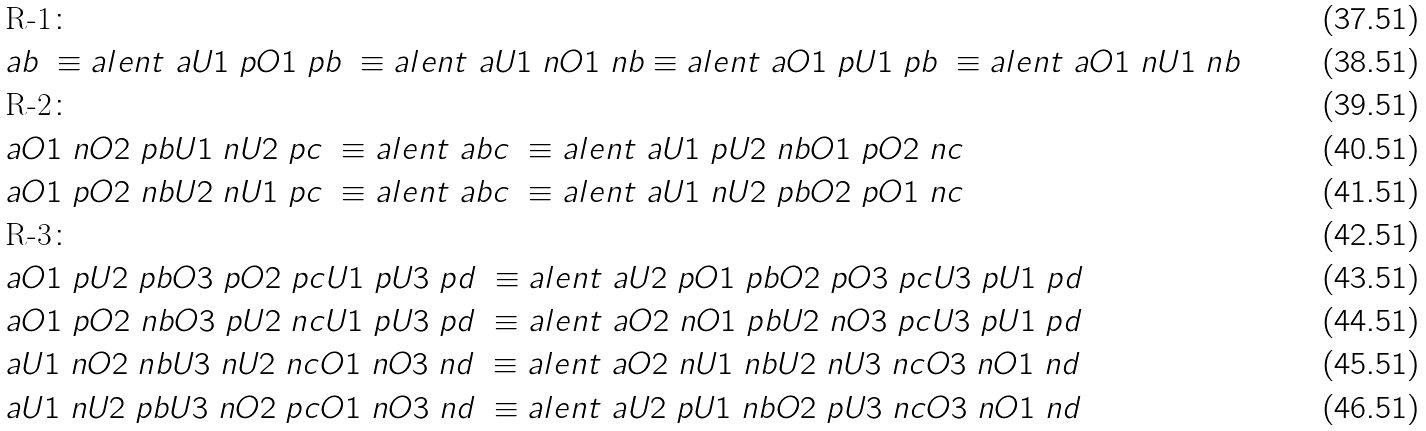<formula> <loc_0><loc_0><loc_500><loc_500>& \text {R-1} \colon \\ & a b \ \equiv a l e n t \ a U 1 \ p O 1 \ p b \ \equiv a l e n t \ a U 1 \ n O 1 \ n b \equiv a l e n t \ a O 1 \ p U 1 \ p b \ \equiv a l e n t \ a O 1 \ n U 1 \ n b \\ & \text {R-2} \colon \\ & a O 1 \ n O 2 \ p b U 1 \ n U 2 \ p c \ \equiv a l e n t \ a b c \ \equiv a l e n t \ a U 1 \ p U 2 \ n b O 1 \ p O 2 \ n c \\ & a O 1 \ p O 2 \ n b U 2 \ n U 1 \ p c \ \equiv a l e n t \ a b c \ \equiv a l e n t \ a U 1 \ n U 2 \ p b O 2 \ p O 1 \ n c \\ & \text {R-3} \colon \\ & a O 1 \ p U 2 \ p b O 3 \ p O 2 \ p c U 1 \ p U 3 \ p d \ \equiv a l e n t \ a U 2 \ p O 1 \ p b O 2 \ p O 3 \ p c U 3 \ p U 1 \ p d \\ & a O 1 \ p O 2 \ n b O 3 \ p U 2 \ n c U 1 \ p U 3 \ p d \ \equiv a l e n t \ a O 2 \ n O 1 \ p b U 2 \ n O 3 \ p c U 3 \ p U 1 \ p d \\ & a U 1 \ n O 2 \ n b U 3 \ n U 2 \ n c O 1 \ n O 3 \ n d \ \equiv a l e n t \ a O 2 \ n U 1 \ n b U 2 \ n U 3 \ n c O 3 \ n O 1 \ n d \\ & a U 1 \ n U 2 \ p b U 3 \ n O 2 \ p c O 1 \ n O 3 \ n d \ \equiv a l e n t \ a U 2 \ p U 1 \ n b O 2 \ p U 3 \ n c O 3 \ n O 1 \ n d</formula> 